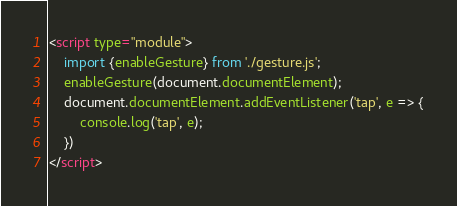<code> <loc_0><loc_0><loc_500><loc_500><_HTML_>

<script type="module">
    import {enableGesture} from './gesture.js';
    enableGesture(document.documentElement);
    document.documentElement.addEventListener('tap', e => {
        console.log('tap', e);
    })
</script></code> 